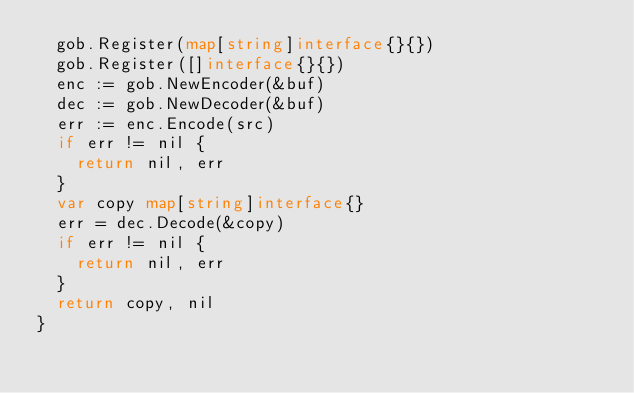<code> <loc_0><loc_0><loc_500><loc_500><_Go_>	gob.Register(map[string]interface{}{})
	gob.Register([]interface{}{})
	enc := gob.NewEncoder(&buf)
	dec := gob.NewDecoder(&buf)
	err := enc.Encode(src)
	if err != nil {
		return nil, err
	}
	var copy map[string]interface{}
	err = dec.Decode(&copy)
	if err != nil {
		return nil, err
	}
	return copy, nil
}
</code> 